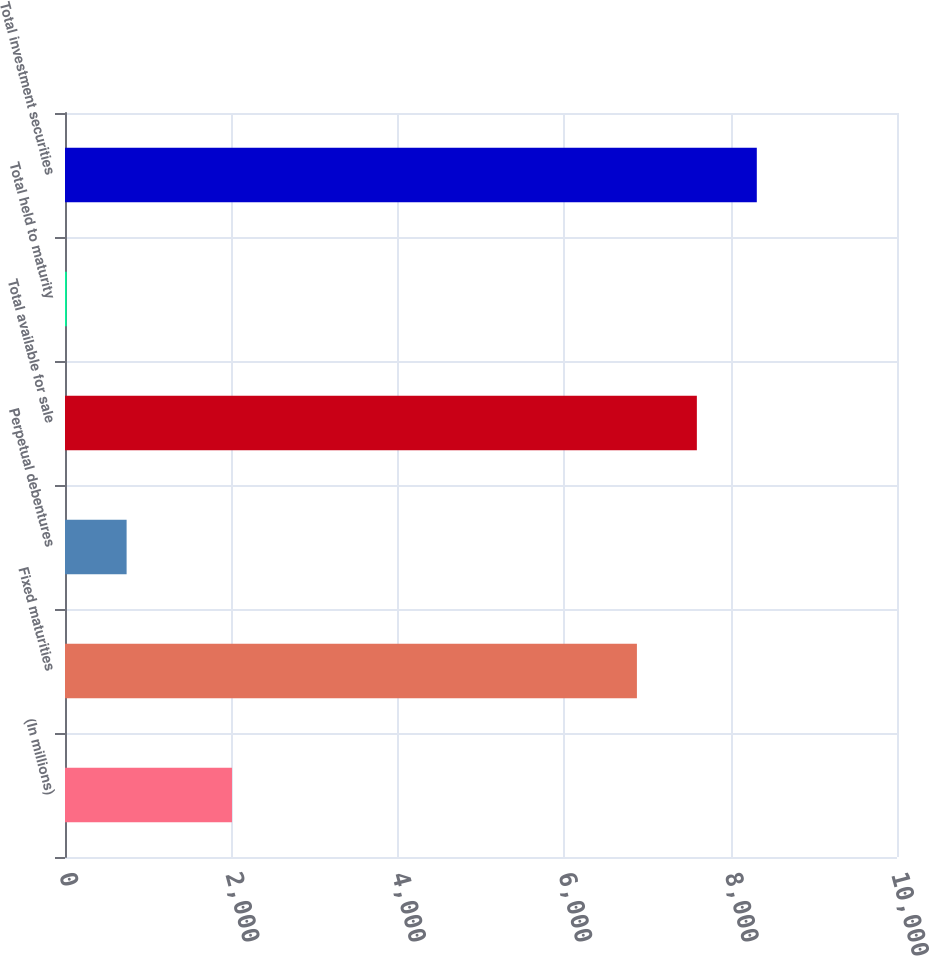<chart> <loc_0><loc_0><loc_500><loc_500><bar_chart><fcel>(In millions)<fcel>Fixed maturities<fcel>Perpetual debentures<fcel>Total available for sale<fcel>Total held to maturity<fcel>Total investment securities<nl><fcel>2007<fcel>6874<fcel>740.5<fcel>7594.5<fcel>20<fcel>8315<nl></chart> 